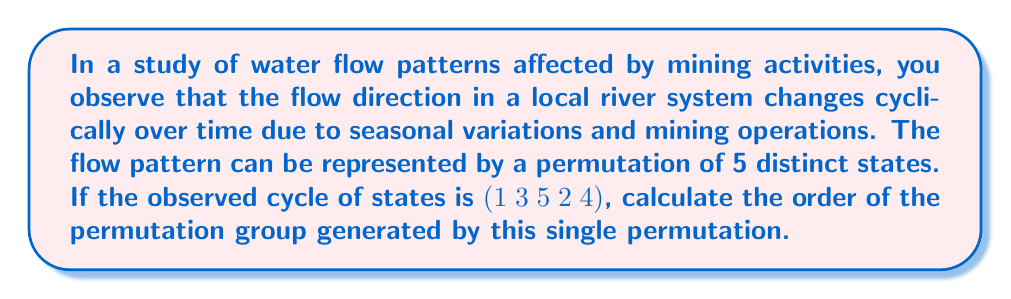Solve this math problem. To solve this problem, we need to understand the concept of permutation cycles and how to determine the order of a permutation group generated by a single permutation.

1. First, let's write the permutation in cycle notation:
   $$(1 \; 3 \; 5 \; 2 \; 4)$$

2. The order of a permutation is the smallest positive integer $n$ such that $\sigma^n = e$, where $e$ is the identity permutation.

3. For a single cycle, the order is equal to the length of the cycle. In this case, we have a 5-cycle.

4. Therefore, the order of this permutation is 5.

5. Since the permutation group is generated by this single permutation, the order of the group is the same as the order of the permutation.

To verify this:
$$\begin{align*}
\sigma &= (1 \; 3 \; 5 \; 2 \; 4) \\
\sigma^2 &= (1 \; 5 \; 4 \; 3 \; 2) \\
\sigma^3 &= (1 \; 2 \; 3 \; 4 \; 5) \\
\sigma^4 &= (1 \; 4 \; 2 \; 5 \; 3) \\
\sigma^5 &= (1)(2)(3)(4)(5) = e
\end{align*}$$

This confirms that the order of the permutation (and thus the group) is indeed 5.
Answer: The order of the permutation group is 5. 